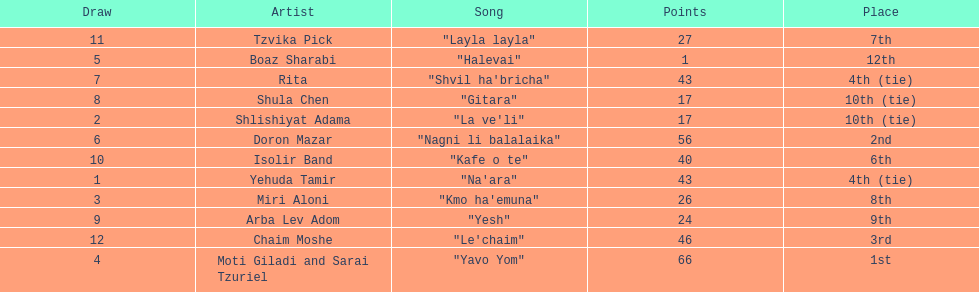What is the total amount of ties in this competition? 2. 